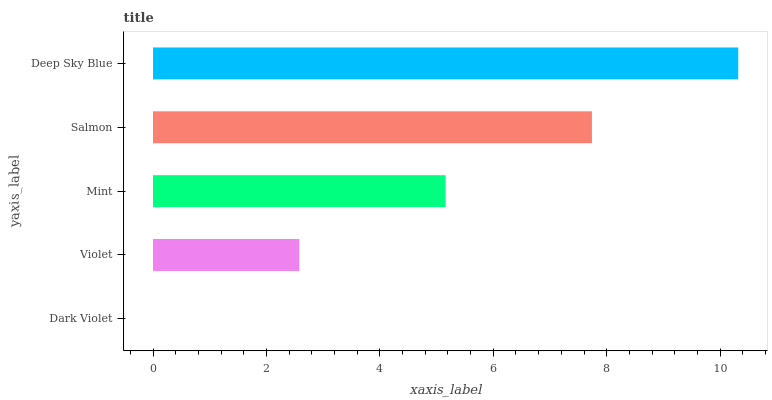Is Dark Violet the minimum?
Answer yes or no. Yes. Is Deep Sky Blue the maximum?
Answer yes or no. Yes. Is Violet the minimum?
Answer yes or no. No. Is Violet the maximum?
Answer yes or no. No. Is Violet greater than Dark Violet?
Answer yes or no. Yes. Is Dark Violet less than Violet?
Answer yes or no. Yes. Is Dark Violet greater than Violet?
Answer yes or no. No. Is Violet less than Dark Violet?
Answer yes or no. No. Is Mint the high median?
Answer yes or no. Yes. Is Mint the low median?
Answer yes or no. Yes. Is Dark Violet the high median?
Answer yes or no. No. Is Dark Violet the low median?
Answer yes or no. No. 